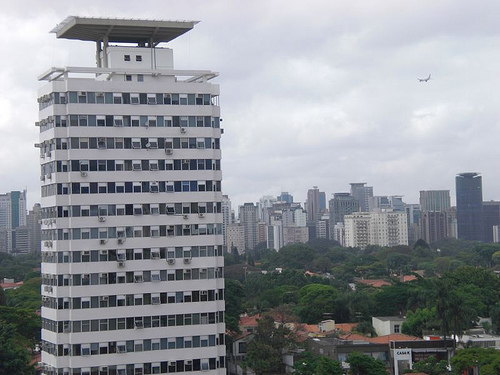<image>
Is the sky behind the building? Yes. From this viewpoint, the sky is positioned behind the building, with the building partially or fully occluding the sky. 